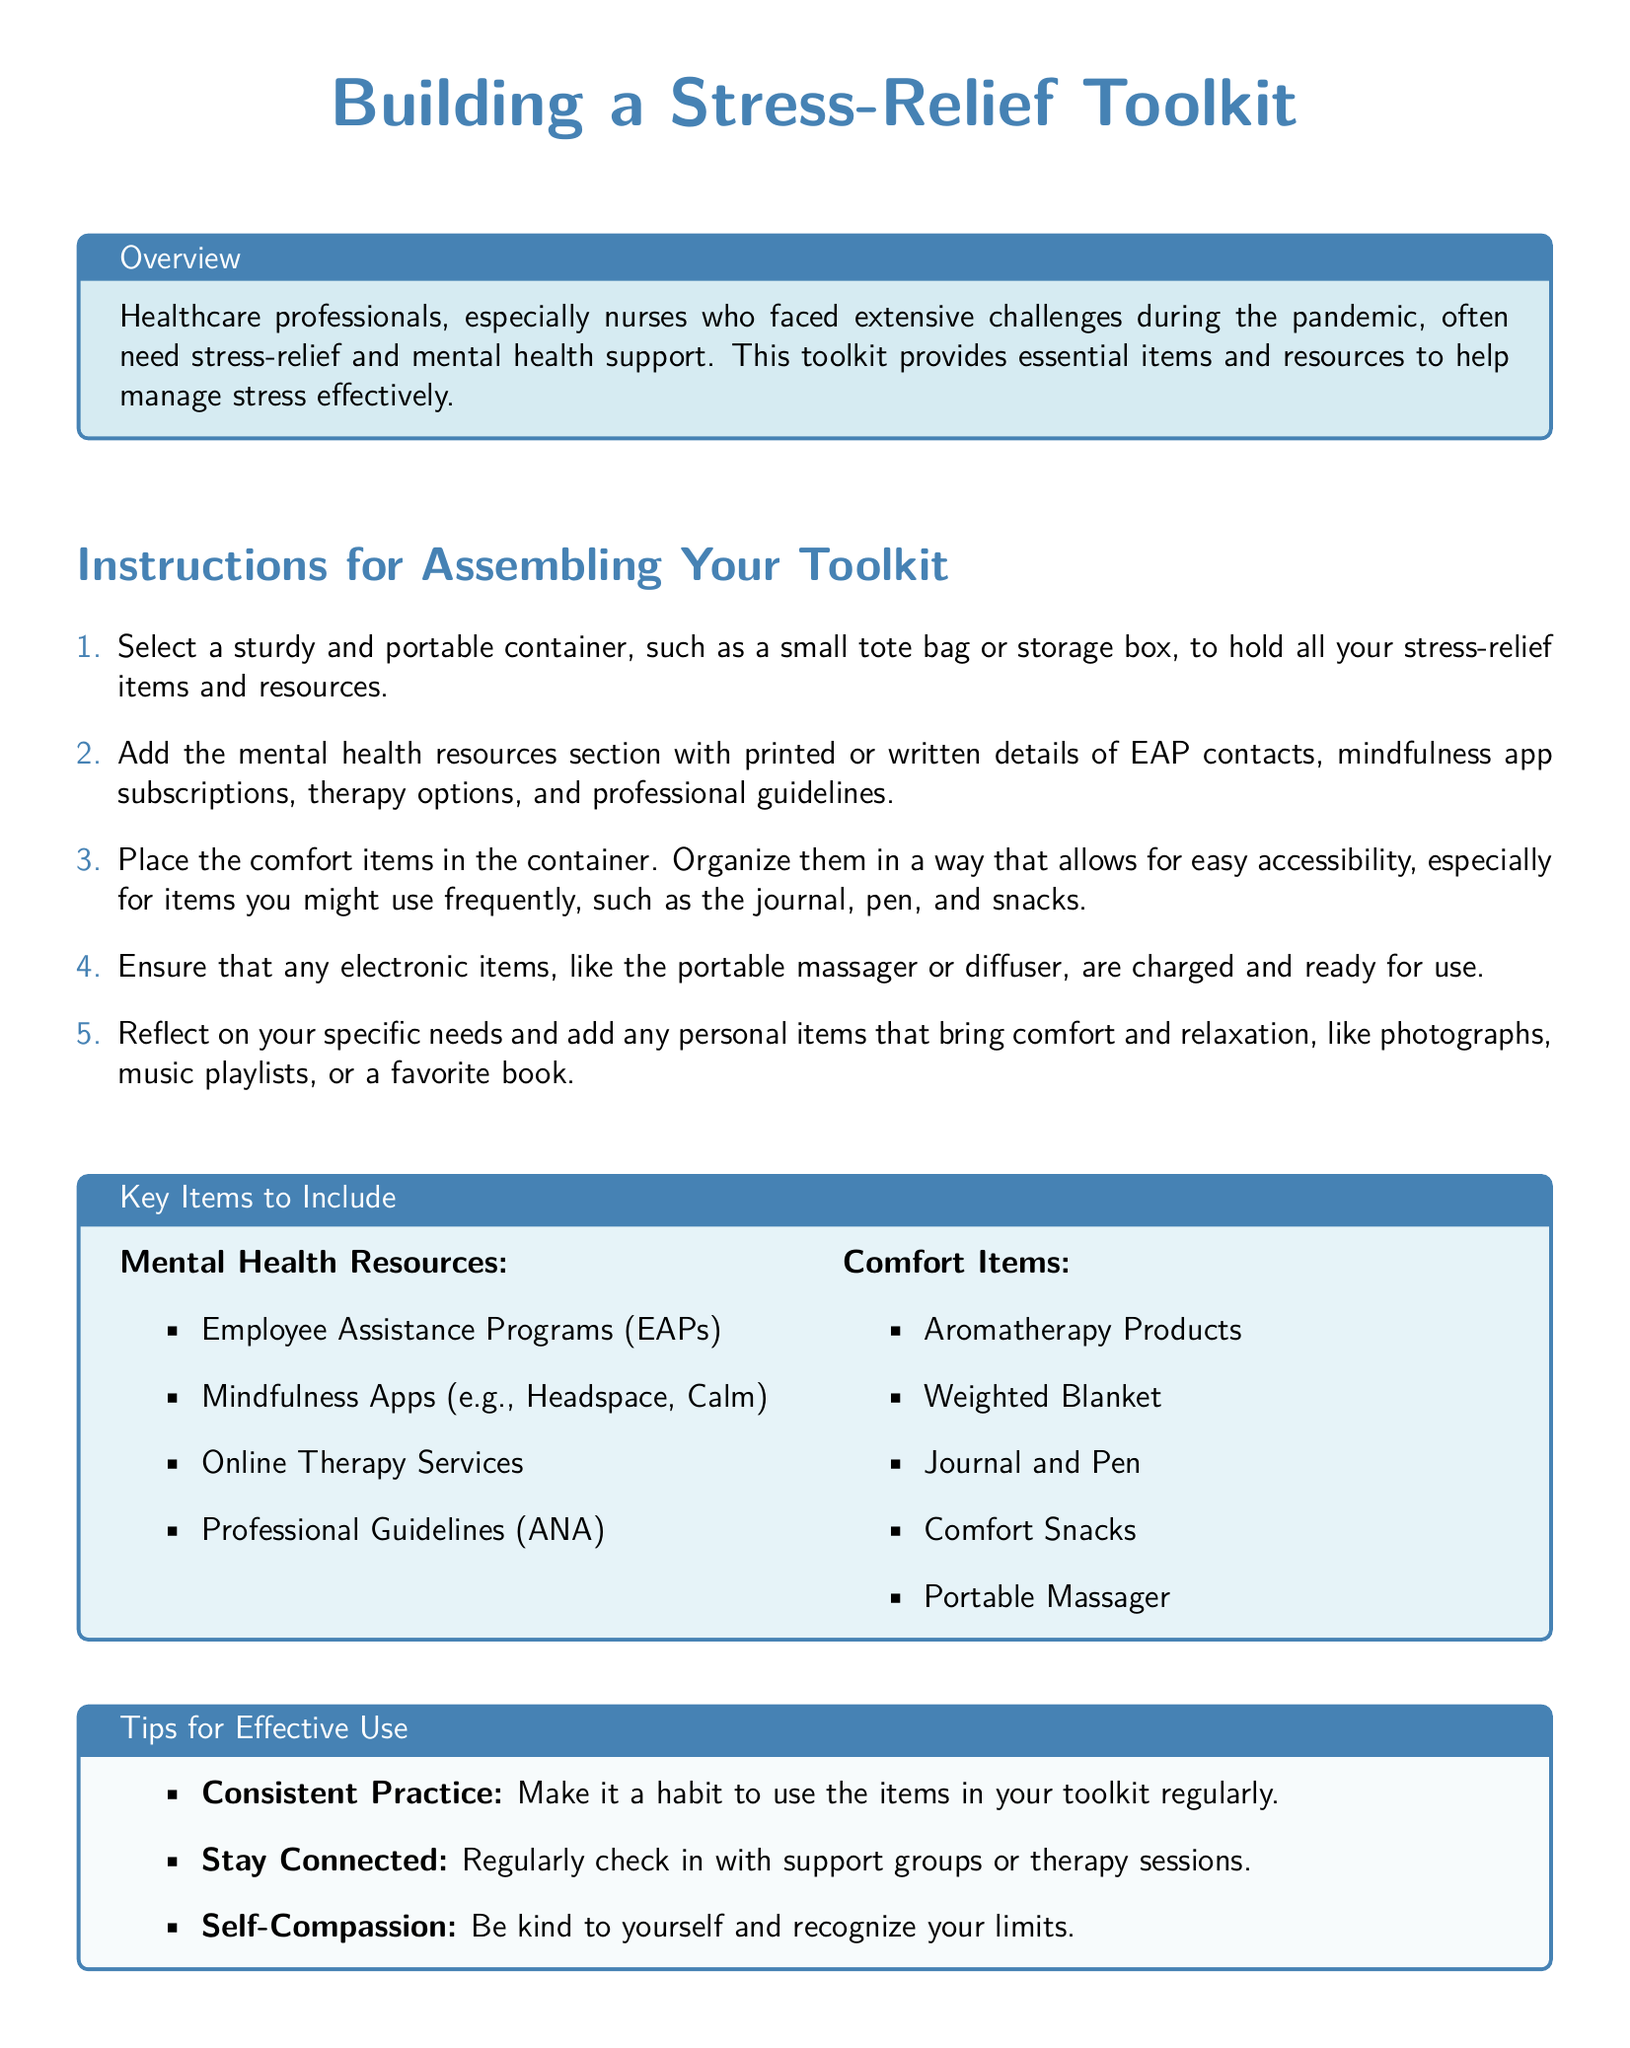What is the title of the document? The title is prominently displayed at the top of the document, indicating the main focus of the content.
Answer: Building a Stress-Relief Toolkit What color is used for the section titles? The color used for the section titles is specified within the document to enhance readability.
Answer: Nurse blue How many key items are listed under Mental Health Resources? The number of items is explicitly mentioned in the bulleted list within the boxed section of the toolkit.
Answer: Four What should you select as a container for the toolkit? The instructions detail the type of container recommended for holding the items and resources in the toolkit.
Answer: Sturdy and portable container What comfort item is mentioned that provides tactile weight? The document lists various comfort items, including one specified for its physical properties.
Answer: Weighted Blanket How should electronic items in the toolkit be prepared? The instructions emphasize the importance of readiness for specific electronic items.
Answer: Charged and ready for use What is the purpose of the toolkit as described in the overview? The overview section explains the need for this toolkit among healthcare professionals during a difficult time.
Answer: Stress-relief and mental health support Which mindfulness apps are suggested in the resources? The key resources section names some apps that could be beneficial for mental health support.
Answer: Headspace, Calm How many tips for effective use are provided in the document? The document lists several tips, indicating how many to consider for optimal use of the toolkit items.
Answer: Three 